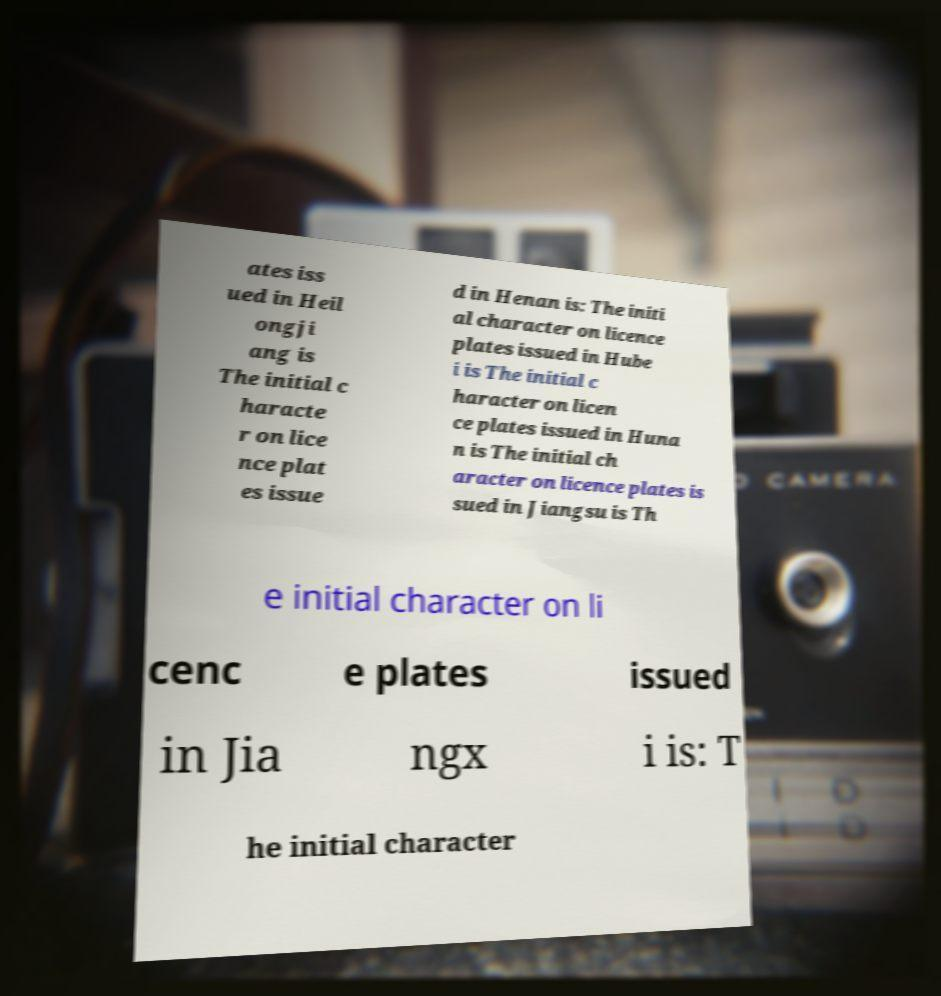Could you assist in decoding the text presented in this image and type it out clearly? ates iss ued in Heil ongji ang is The initial c haracte r on lice nce plat es issue d in Henan is: The initi al character on licence plates issued in Hube i is The initial c haracter on licen ce plates issued in Huna n is The initial ch aracter on licence plates is sued in Jiangsu is Th e initial character on li cenc e plates issued in Jia ngx i is: T he initial character 